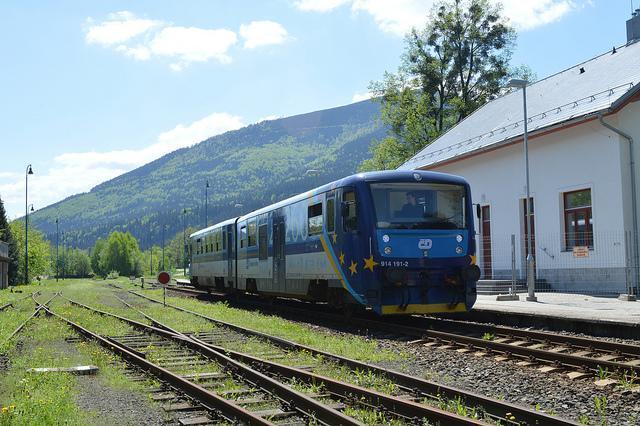How many tracks are in the shot?
Give a very brief answer. 4. 